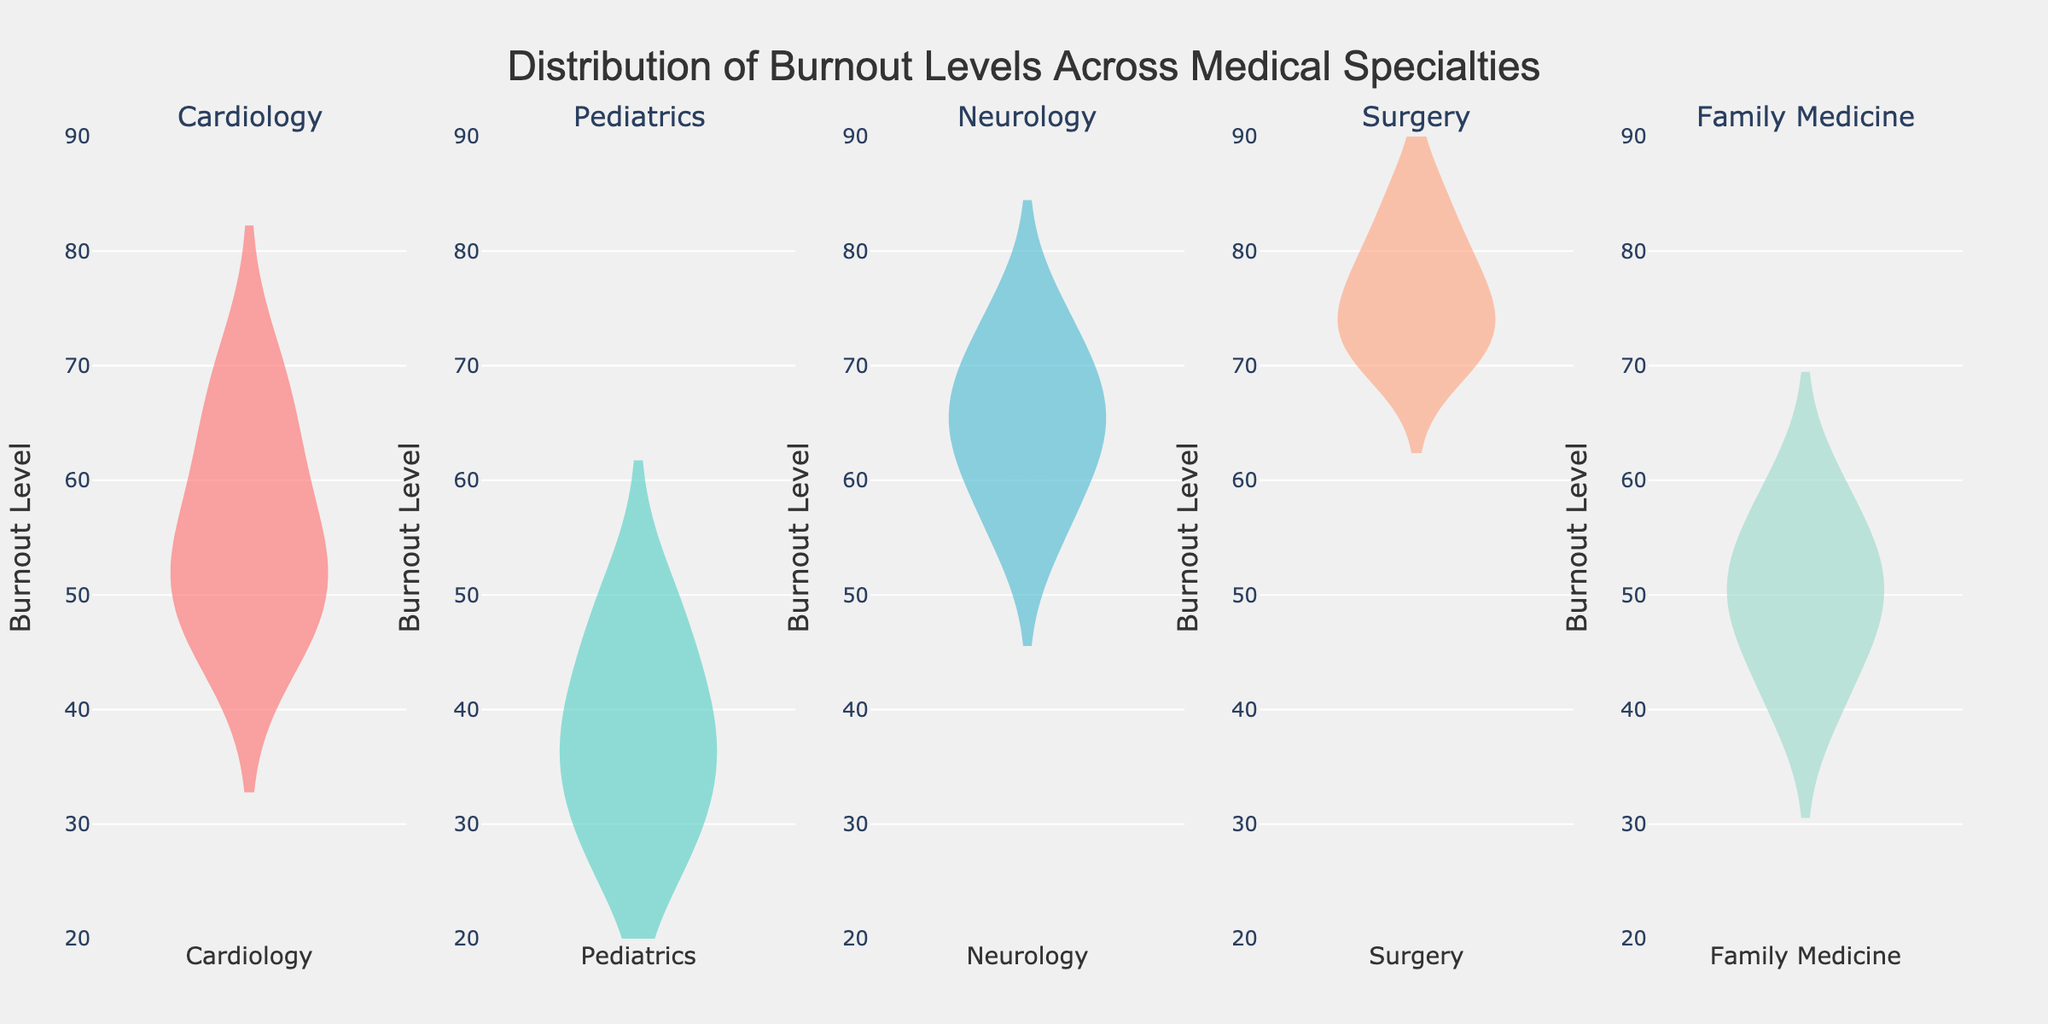What is the title of the chart? The title is displayed at the top center of the chart and reads "Distribution of Burnout Levels Across Medical Specialties".
Answer: Distribution of Burnout Levels Across Medical Specialties What is the y-axis label? The y-axis label is located at the left side of the chart and reads "Burnout Level".
Answer: Burnout Level How many different medical specialties are shown in the chart? The subplots each correspond to a unique medical specialty, and there are five subplots in total.
Answer: 5 Which specialty has the widest range of burnout levels? By comparing the ranges of the burnout levels for each specialty violin plot, Surgery spans burnout levels from approximately 70 to 85, making it the widest range.
Answer: Surgery What is the most common burnout level in the Neurology specialty? The violin plot for Neurology has a thick region around the burnout level of 65, indicating it is the most common burnout level.
Answer: 65 Which specialty shows the lowest minimum burnout level? Pediatrics has the lowest minimum burnout level, which is around 27, as seen by the bottom of the violin plot.
Answer: Pediatrics Compare the median burnout levels between Cardiology and Family Medicine specialties. The median is represented by a horizontal line inside the box on the violin plots. Cardiology has a median around 53, and Family Medicine has a median around 50.
Answer: Cardiology: 53, Family Medicine: 50 What is the interquartile range (IQR) for the Burnout Levels in the Family Medicine specialty? The IQR is calculated by finding the range between the first quartile (Q1) and the third quartile (Q3). For Family Medicine, Q1 is around 45, and Q3 is around 55. The IQR is therefore 55 - 45 = 10.
Answer: 10 Which specialty has burnout levels that do not go below 70? By examining the starting points of each violin plot, it is seen that Surgery has burnout levels that start at 70 and go upwards.
Answer: Surgery 